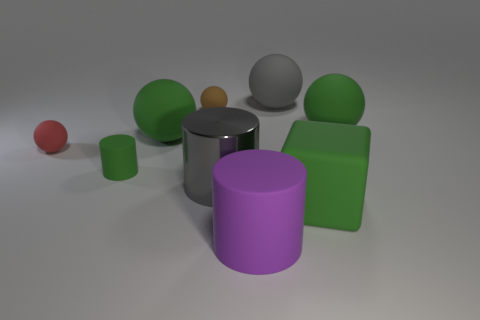What shape is the other big thing that is the same color as the shiny object?
Ensure brevity in your answer.  Sphere. What size is the gray ball that is made of the same material as the big purple cylinder?
Keep it short and to the point. Large. Are there any tiny matte things that have the same color as the large metal cylinder?
Make the answer very short. No. There is a large rubber thing that is on the left side of the purple matte object; is it the same color as the small matte ball that is to the right of the green cylinder?
Offer a very short reply. No. What is the size of the matte cube that is the same color as the small cylinder?
Your response must be concise. Large. Is there a big red cylinder made of the same material as the tiny cylinder?
Ensure brevity in your answer.  No. The block has what color?
Your response must be concise. Green. What is the size of the gray thing that is behind the large green rubber sphere that is right of the big matte ball left of the brown sphere?
Keep it short and to the point. Large. What number of other things are there of the same shape as the metallic thing?
Keep it short and to the point. 2. There is a object that is both in front of the large shiny object and right of the large matte cylinder; what color is it?
Provide a short and direct response. Green. 